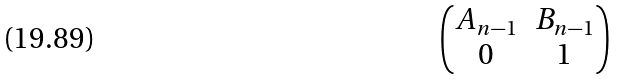Convert formula to latex. <formula><loc_0><loc_0><loc_500><loc_500>\begin{pmatrix} A _ { n - 1 } & B _ { n - 1 } \\ 0 & 1 \end{pmatrix}</formula> 